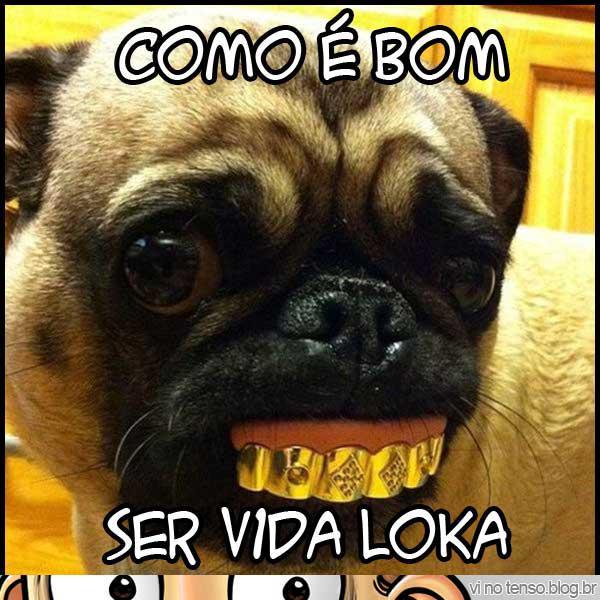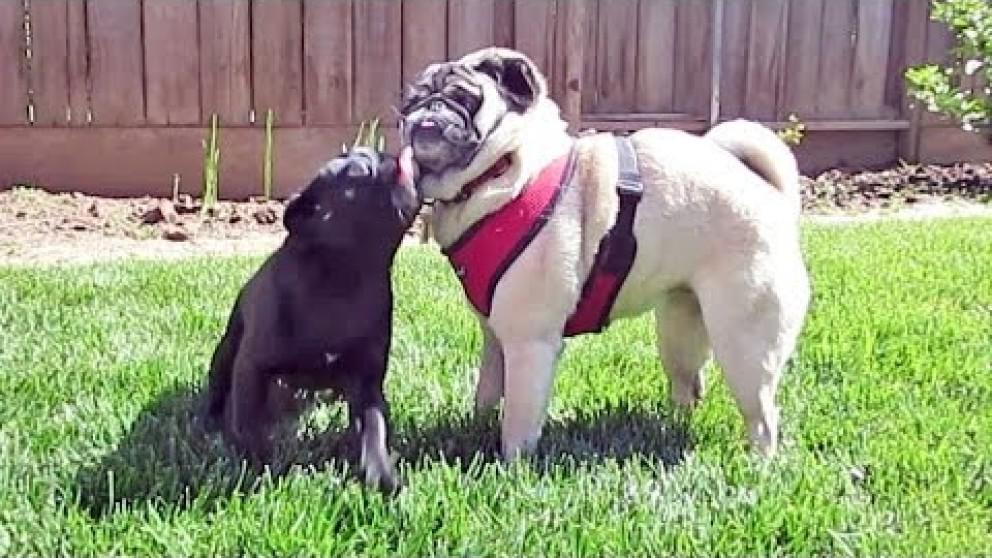The first image is the image on the left, the second image is the image on the right. Assess this claim about the two images: "There is two dogs in the right image.". Correct or not? Answer yes or no. Yes. The first image is the image on the left, the second image is the image on the right. Assess this claim about the two images: "One image shows a smaller black dog next to a buff-beige pug.". Correct or not? Answer yes or no. Yes. 